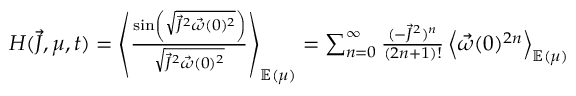Convert formula to latex. <formula><loc_0><loc_0><loc_500><loc_500>\begin{array} { r } { H ( \vec { J } , \mu , t ) = \left \langle \frac { \sin \left ( \sqrt { \vec { J } ^ { 2 } \vec { \omega } ( 0 ) ^ { 2 } } \right ) } { \sqrt { \vec { J } ^ { 2 } \vec { \omega } ( 0 ) ^ { 2 } } } \right \rangle _ { \mathbb { E } ( \mu ) } = \sum _ { n = 0 } ^ { \infty } \frac { ( - \vec { J } ^ { 2 } ) ^ { n } } { ( 2 n + 1 ) ! } \left \langle \vec { \omega } ( 0 ) ^ { 2 n } \right \rangle _ { \mathbb { E } ( \mu ) } } \end{array}</formula> 